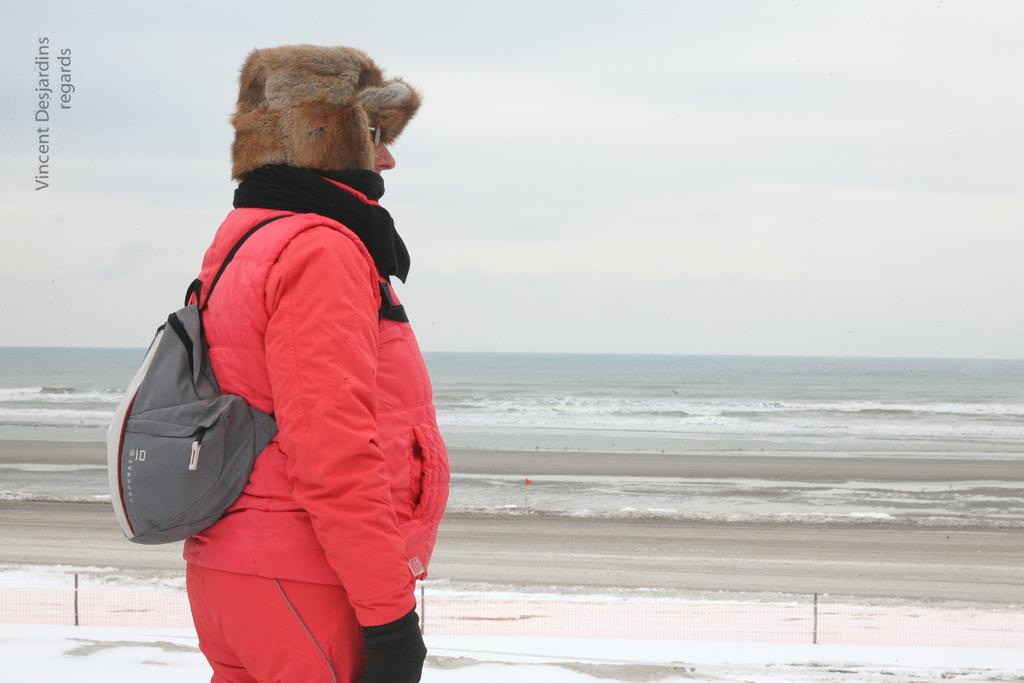What is the main subject of the image? There is a person in the image. What accessories is the person wearing? The person is wearing a cap, specs, and gloves. What is the person carrying in the image? The person is carrying a bag. What natural elements can be seen in the image? There is water and sky visible in the image. Is there any additional information about the image itself? There is a watermark in the right top corner of the image. How many pies can be seen on the roof in the image? There are no pies or roof present in the image. What type of snow can be seen falling in the image? There is no snow visible in the image. 